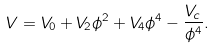<formula> <loc_0><loc_0><loc_500><loc_500>V = V _ { 0 } + V _ { 2 } \phi ^ { 2 } + V _ { 4 } \phi ^ { 4 } - \frac { V _ { c } } { \phi ^ { 4 } } .</formula> 